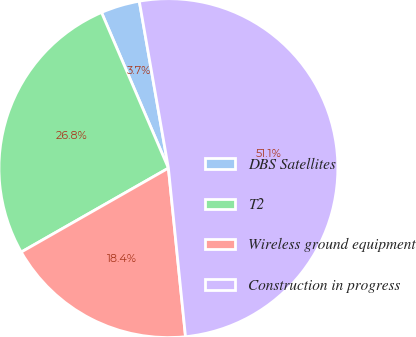Convert chart. <chart><loc_0><loc_0><loc_500><loc_500><pie_chart><fcel>DBS Satellites<fcel>T2<fcel>Wireless ground equipment<fcel>Construction in progress<nl><fcel>3.71%<fcel>26.79%<fcel>18.36%<fcel>51.14%<nl></chart> 